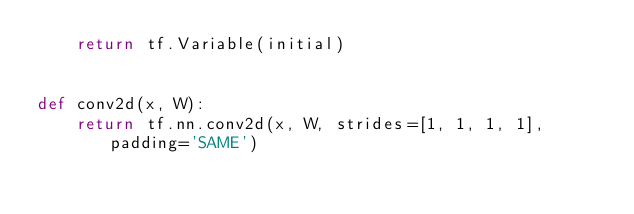Convert code to text. <code><loc_0><loc_0><loc_500><loc_500><_Python_>    return tf.Variable(initial)


def conv2d(x, W):
    return tf.nn.conv2d(x, W, strides=[1, 1, 1, 1], padding='SAME')

</code> 